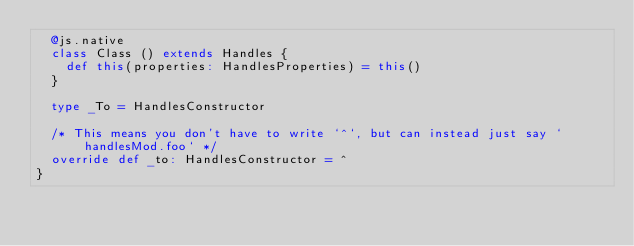Convert code to text. <code><loc_0><loc_0><loc_500><loc_500><_Scala_>  @js.native
  class Class () extends Handles {
    def this(properties: HandlesProperties) = this()
  }
  
  type _To = HandlesConstructor
  
  /* This means you don't have to write `^`, but can instead just say `handlesMod.foo` */
  override def _to: HandlesConstructor = ^
}
</code> 